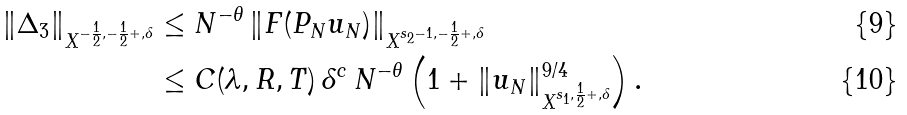Convert formula to latex. <formula><loc_0><loc_0><loc_500><loc_500>\| \Delta _ { 3 } \| _ { X ^ { - \frac { 1 } { 2 } , - \frac { 1 } { 2 } + , \delta } } & \leq N ^ { - \theta } \, \| F ( P _ { N } u _ { N } ) \| _ { X ^ { s _ { 2 } - 1 , - \frac { 1 } { 2 } + , \delta } } \\ & \leq C ( \lambda , R , T ) \, \delta ^ { c } \, N ^ { - \theta } \left ( 1 + \| u _ { N } \| ^ { 9 / 4 } _ { X ^ { s _ { 1 } , \frac { 1 } { 2 } + , \delta } } \right ) .</formula> 